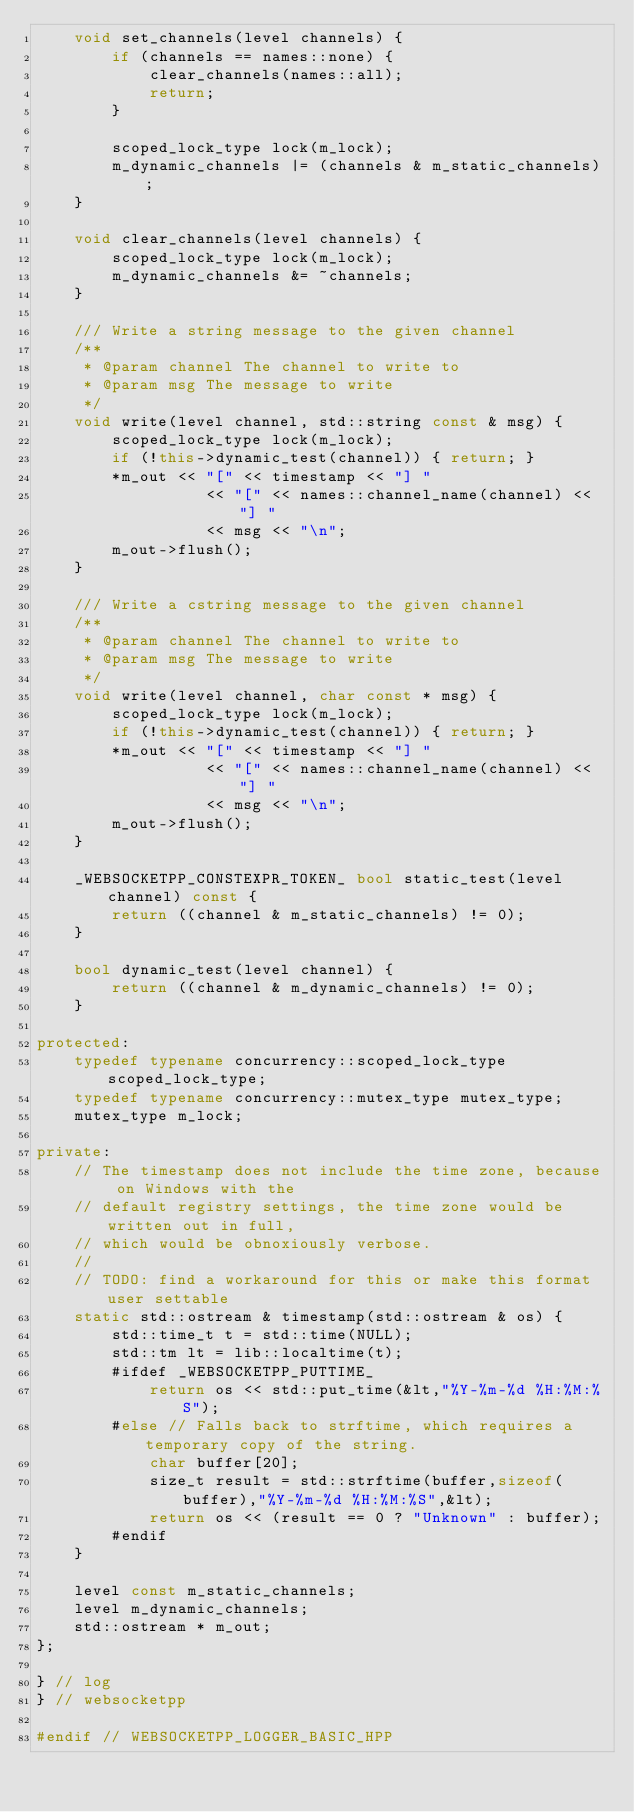<code> <loc_0><loc_0><loc_500><loc_500><_C++_>    void set_channels(level channels) {
        if (channels == names::none) {
            clear_channels(names::all);
            return;
        }

        scoped_lock_type lock(m_lock);
        m_dynamic_channels |= (channels & m_static_channels);
    }

    void clear_channels(level channels) {
        scoped_lock_type lock(m_lock);
        m_dynamic_channels &= ~channels;
    }

    /// Write a string message to the given channel
    /**
     * @param channel The channel to write to
     * @param msg The message to write
     */
    void write(level channel, std::string const & msg) {
        scoped_lock_type lock(m_lock);
        if (!this->dynamic_test(channel)) { return; }
        *m_out << "[" << timestamp << "] "
                  << "[" << names::channel_name(channel) << "] "
                  << msg << "\n";
        m_out->flush();
    }

    /// Write a cstring message to the given channel
    /**
     * @param channel The channel to write to
     * @param msg The message to write
     */
    void write(level channel, char const * msg) {
        scoped_lock_type lock(m_lock);
        if (!this->dynamic_test(channel)) { return; }
        *m_out << "[" << timestamp << "] "
                  << "[" << names::channel_name(channel) << "] "
                  << msg << "\n";
        m_out->flush();
    }

    _WEBSOCKETPP_CONSTEXPR_TOKEN_ bool static_test(level channel) const {
        return ((channel & m_static_channels) != 0);
    }

    bool dynamic_test(level channel) {
        return ((channel & m_dynamic_channels) != 0);
    }

protected:
    typedef typename concurrency::scoped_lock_type scoped_lock_type;
    typedef typename concurrency::mutex_type mutex_type;
    mutex_type m_lock;

private:
    // The timestamp does not include the time zone, because on Windows with the
    // default registry settings, the time zone would be written out in full,
    // which would be obnoxiously verbose.
    //
    // TODO: find a workaround for this or make this format user settable
    static std::ostream & timestamp(std::ostream & os) {
        std::time_t t = std::time(NULL);
        std::tm lt = lib::localtime(t);
        #ifdef _WEBSOCKETPP_PUTTIME_
            return os << std::put_time(&lt,"%Y-%m-%d %H:%M:%S");
        #else // Falls back to strftime, which requires a temporary copy of the string.
            char buffer[20];
            size_t result = std::strftime(buffer,sizeof(buffer),"%Y-%m-%d %H:%M:%S",&lt);
            return os << (result == 0 ? "Unknown" : buffer);
        #endif
    }

    level const m_static_channels;
    level m_dynamic_channels;
    std::ostream * m_out;
};

} // log
} // websocketpp

#endif // WEBSOCKETPP_LOGGER_BASIC_HPP
</code> 